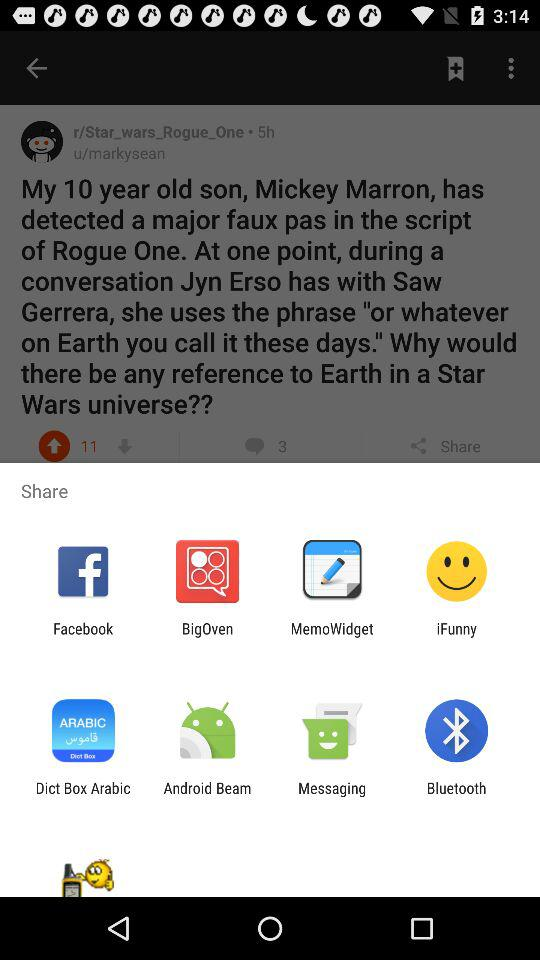What is the son's age? The son is 10 years old. 